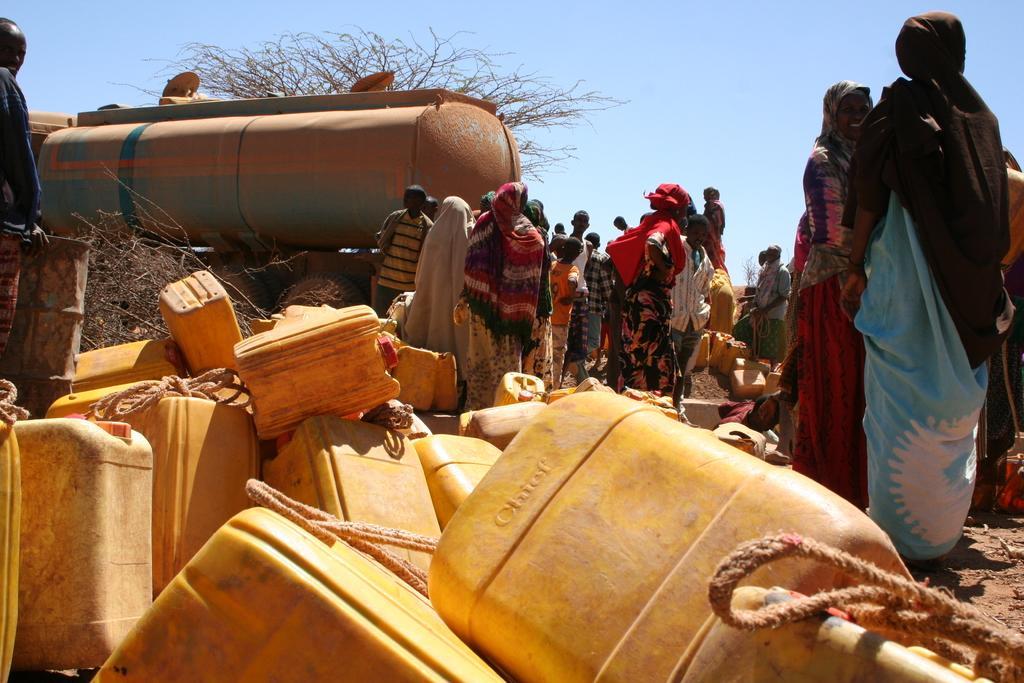Could you give a brief overview of what you see in this image? In the foreground of the pictures there are plastic containers, drums, women, soil and a man. In the center of the picture there are women, plastic containers, a big iron container, trees and other objects. Sky is sunny. 